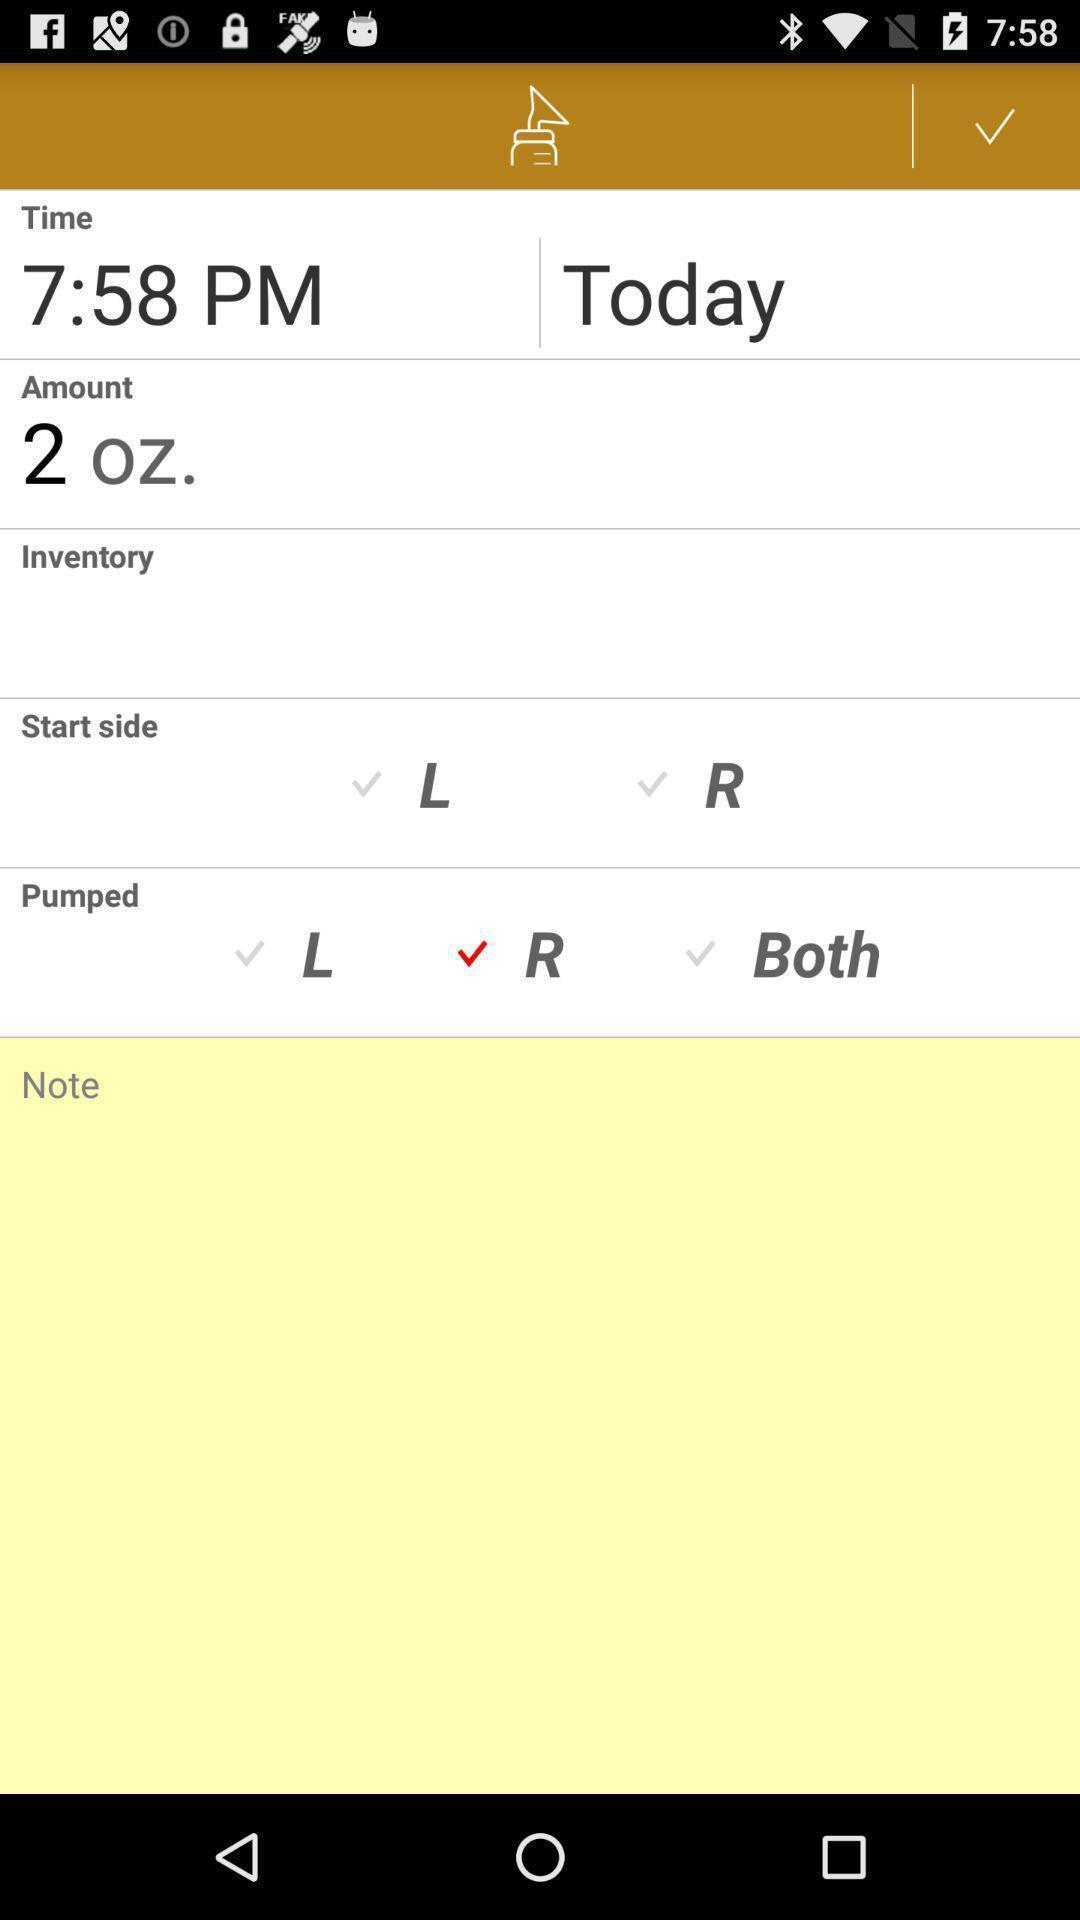Give me a narrative description of this picture. Page displaying time. 